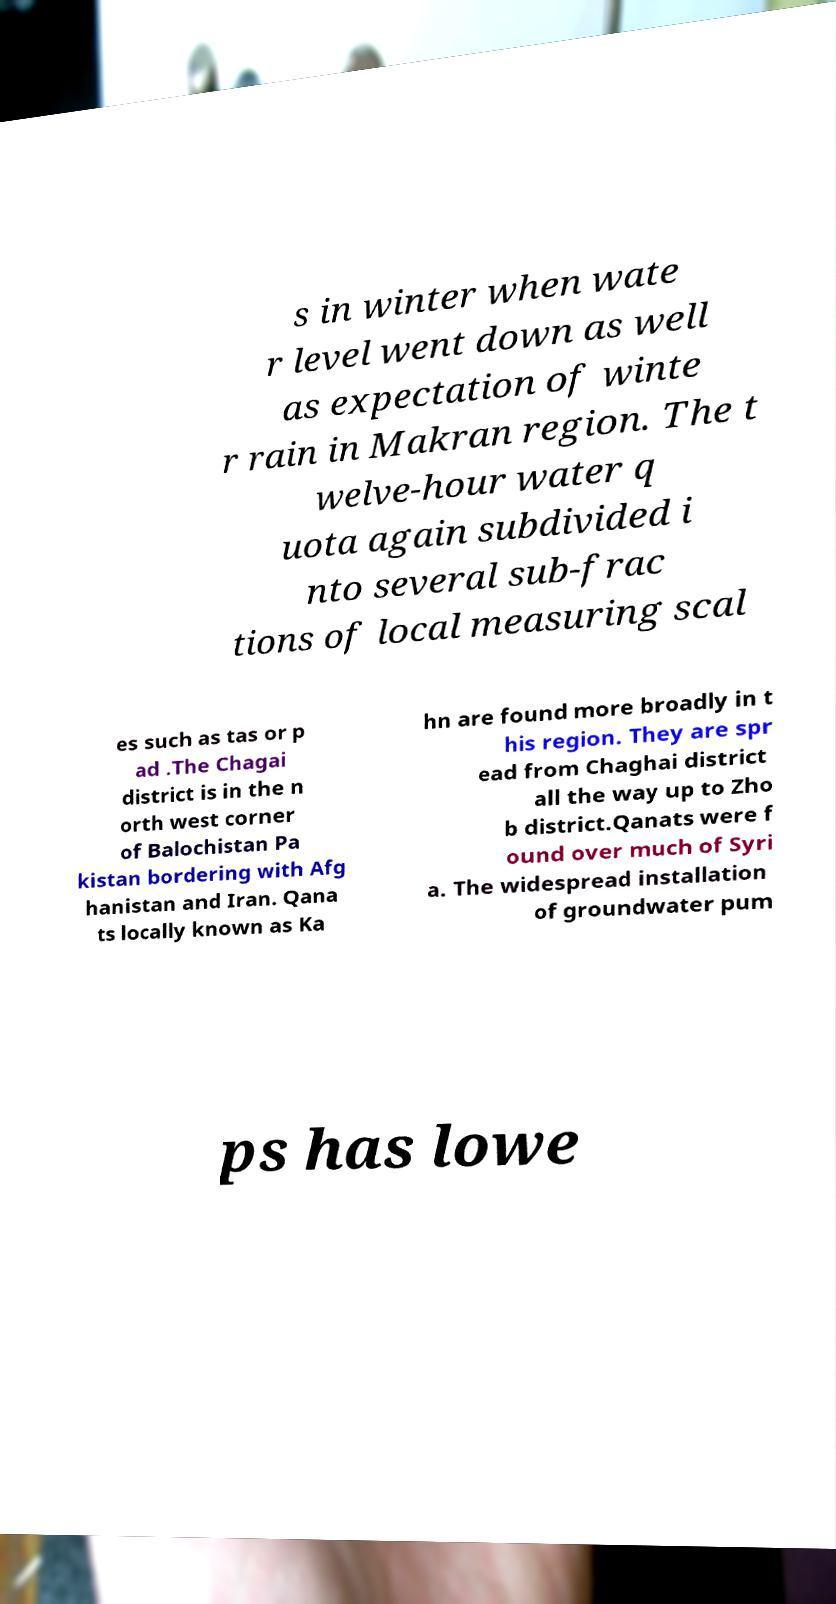I need the written content from this picture converted into text. Can you do that? s in winter when wate r level went down as well as expectation of winte r rain in Makran region. The t welve-hour water q uota again subdivided i nto several sub-frac tions of local measuring scal es such as tas or p ad .The Chagai district is in the n orth west corner of Balochistan Pa kistan bordering with Afg hanistan and Iran. Qana ts locally known as Ka hn are found more broadly in t his region. They are spr ead from Chaghai district all the way up to Zho b district.Qanats were f ound over much of Syri a. The widespread installation of groundwater pum ps has lowe 